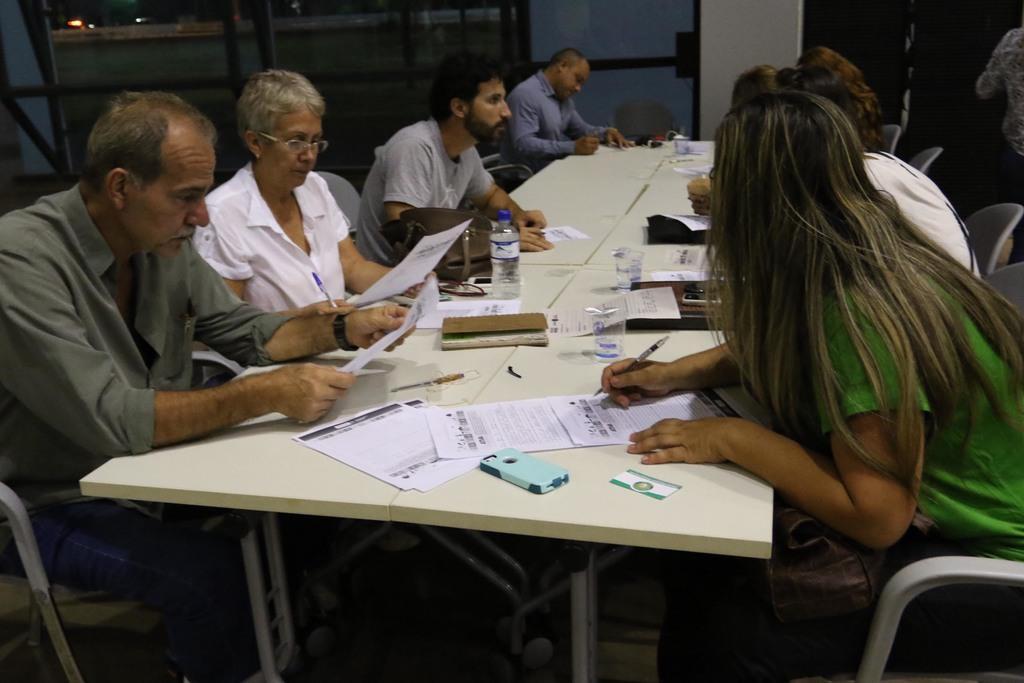Can you describe this image briefly? There are some people sitting around the table in the chairs. On the table there are some papers, pens, mobile phones and water bottles were there. There are men and women in this group. In the background there is a door. 